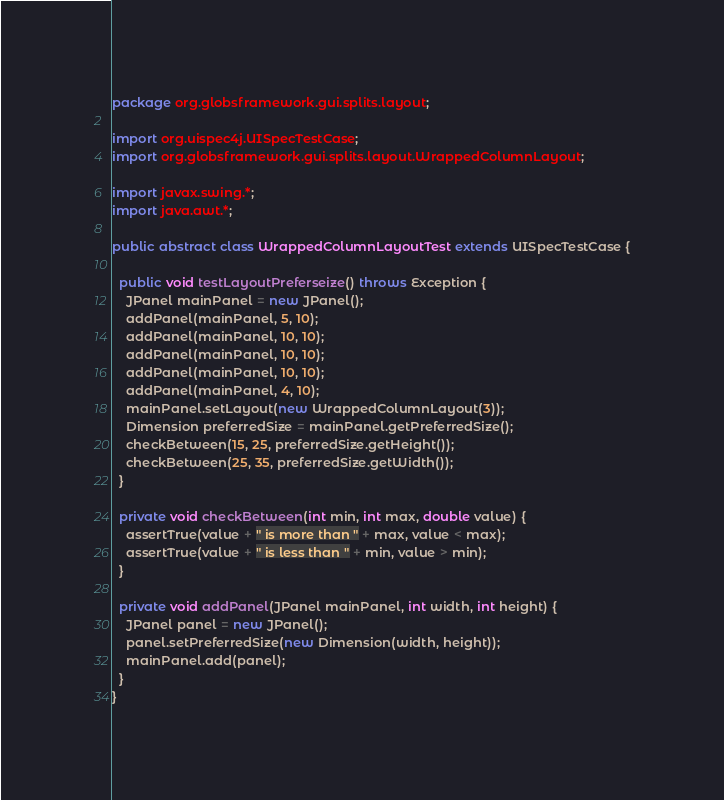<code> <loc_0><loc_0><loc_500><loc_500><_Java_>package org.globsframework.gui.splits.layout;

import org.uispec4j.UISpecTestCase;
import org.globsframework.gui.splits.layout.WrappedColumnLayout;

import javax.swing.*;
import java.awt.*;

public abstract class WrappedColumnLayoutTest extends UISpecTestCase {

  public void testLayoutPreferseize() throws Exception {
    JPanel mainPanel = new JPanel();
    addPanel(mainPanel, 5, 10);
    addPanel(mainPanel, 10, 10);
    addPanel(mainPanel, 10, 10);
    addPanel(mainPanel, 10, 10);
    addPanel(mainPanel, 4, 10);
    mainPanel.setLayout(new WrappedColumnLayout(3));
    Dimension preferredSize = mainPanel.getPreferredSize();
    checkBetween(15, 25, preferredSize.getHeight());
    checkBetween(25, 35, preferredSize.getWidth());
  }

  private void checkBetween(int min, int max, double value) {
    assertTrue(value + " is more than " + max, value < max);
    assertTrue(value + " is less than " + min, value > min);
  }

  private void addPanel(JPanel mainPanel, int width, int height) {
    JPanel panel = new JPanel();
    panel.setPreferredSize(new Dimension(width, height));
    mainPanel.add(panel);
  }
}
</code> 